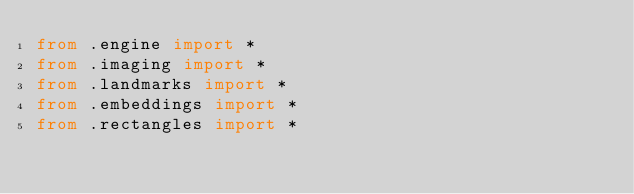<code> <loc_0><loc_0><loc_500><loc_500><_Python_>from .engine import *
from .imaging import *
from .landmarks import *
from .embeddings import *
from .rectangles import *</code> 